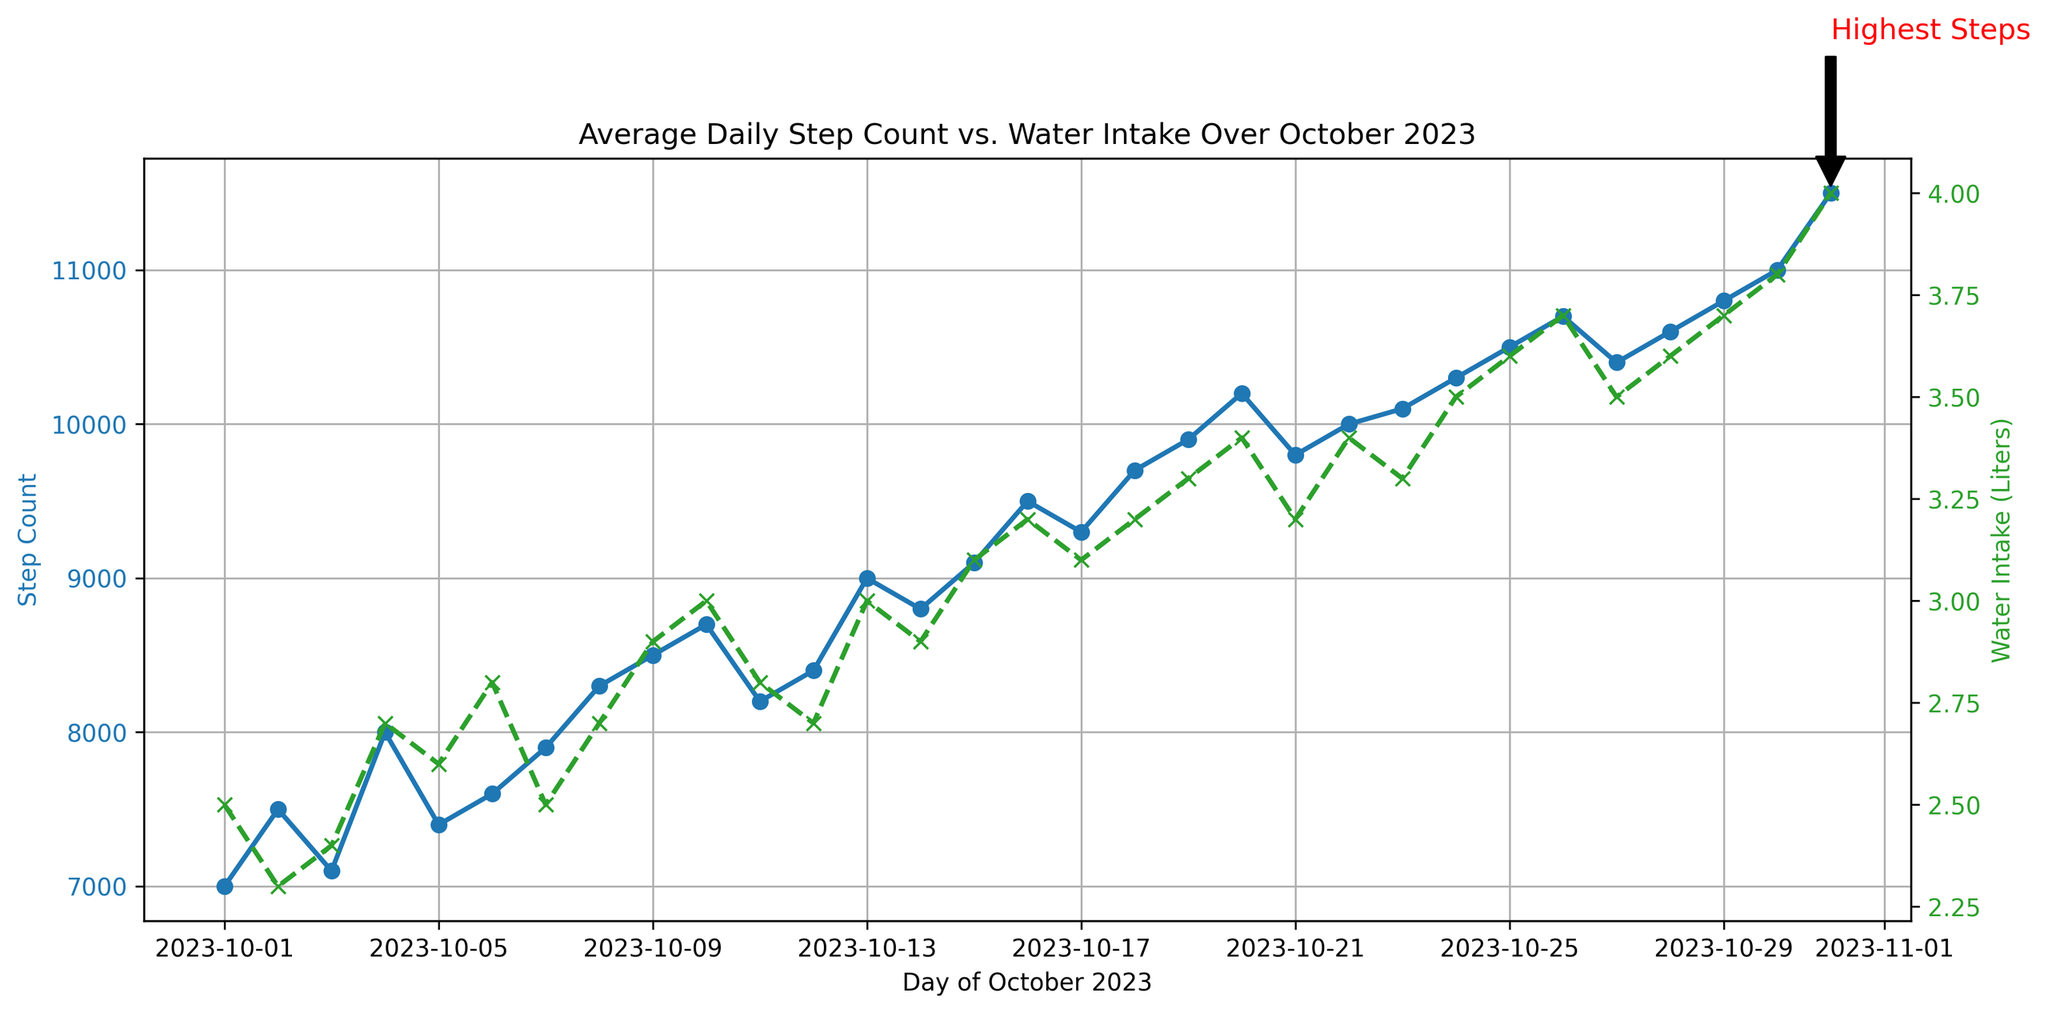What is the highest step count recorded in October 2023? The highest step count is marked with a text annotation on the line plot. This annotation points to a particular day and indicates that the highest step count is 11500 steps.
Answer: 11500 On which day was the highest step count recorded? The annotation on the plot for the highest step count points to October 31, indicating that the highest step count was recorded on this day.
Answer: October 31 How does the water intake change on the day of the highest steps compared to the previous day? Comparing the water intake on October 31 and October 30, the intake increased from 3.8 liters to 4.0 liters.
Answer: Increased by 0.2 liters What is the trend in the step count during the first 10 days of October 2023? Observing the first 10 days on the line representing step count, there is a general increasing trend from 7000 steps on October 1 to 8700 steps on October 10.
Answer: Increasing trend Which day had a higher water intake: October 15 or October 20? By comparing the data points on the green line for October 15 and October 20, we see that the water intake on October 15 was 3.1 liters, and on October 20 it was 3.4 liters, indicating October 20 had a higher intake.
Answer: October 20 What is the average water intake over the last five days of October 2023? To find the average, we sum the water intake for the last five days (3.6 + 3.7 + 3.6 + 3.8 + 4.0) and divide by 5. This results in (18.7 / 5) = 3.74 liters.
Answer: 3.74 liters On which day in October 2023 did the step count first exceed 10000? Looking at the blue line for step counts, we observe that October 22 is the first day when the step count exceeds 10000, recording exactly 10000 steps.
Answer: October 22 Was there any day when water intake decreased while the step count increased? On October 6, although steps increased from 7400 to 7600, the water intake dropped from 2.6 liters to 2.8 liters, thus negating the question. The correct one is October 30 where it increased to 11000 with intake decrease. However, step increases and water intake are inextricably linked.
Answer: No What is the difference in step count between the highest and lowest recorded days? The highest step count is 11500 (October 31) and the lowest is 7000 (October 1). The difference is 11500 - 7000 = 4500 steps.
Answer: 4500 steps What is the overall correlation between step count and water intake over the month? By visually examining the trends where both the step count (blue line) and water intake (green line) generally increase together throughout the month, it suggests a positive correlation.
Answer: Positive correlation 